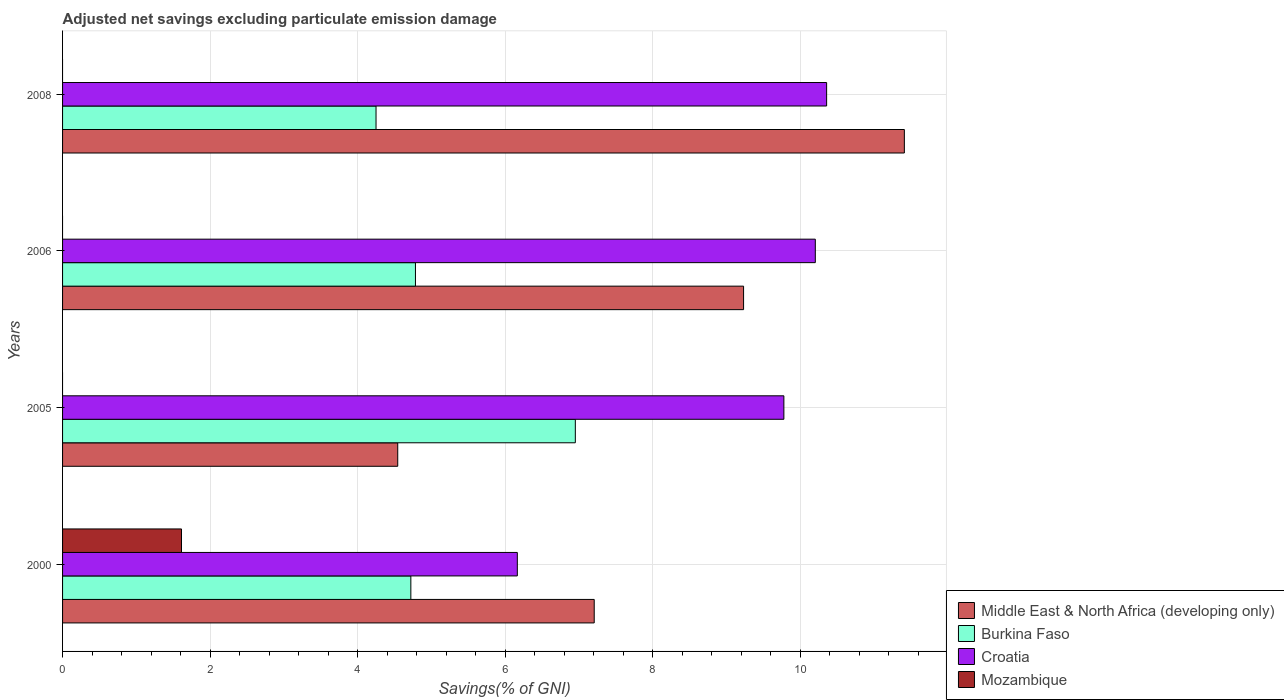How many different coloured bars are there?
Ensure brevity in your answer.  4. How many groups of bars are there?
Keep it short and to the point. 4. Are the number of bars per tick equal to the number of legend labels?
Offer a very short reply. No. How many bars are there on the 4th tick from the top?
Give a very brief answer. 4. In how many cases, is the number of bars for a given year not equal to the number of legend labels?
Offer a very short reply. 3. What is the adjusted net savings in Croatia in 2006?
Provide a short and direct response. 10.2. Across all years, what is the maximum adjusted net savings in Croatia?
Make the answer very short. 10.36. Across all years, what is the minimum adjusted net savings in Mozambique?
Offer a terse response. 0. What is the total adjusted net savings in Burkina Faso in the graph?
Provide a short and direct response. 20.71. What is the difference between the adjusted net savings in Burkina Faso in 2000 and that in 2006?
Offer a very short reply. -0.06. What is the difference between the adjusted net savings in Burkina Faso in 2006 and the adjusted net savings in Croatia in 2000?
Make the answer very short. -1.38. What is the average adjusted net savings in Burkina Faso per year?
Your answer should be compact. 5.18. In the year 2000, what is the difference between the adjusted net savings in Middle East & North Africa (developing only) and adjusted net savings in Burkina Faso?
Offer a very short reply. 2.49. What is the ratio of the adjusted net savings in Middle East & North Africa (developing only) in 2000 to that in 2006?
Offer a terse response. 0.78. Is the difference between the adjusted net savings in Middle East & North Africa (developing only) in 2000 and 2005 greater than the difference between the adjusted net savings in Burkina Faso in 2000 and 2005?
Your response must be concise. Yes. What is the difference between the highest and the second highest adjusted net savings in Middle East & North Africa (developing only)?
Provide a short and direct response. 2.18. What is the difference between the highest and the lowest adjusted net savings in Burkina Faso?
Your answer should be compact. 2.7. In how many years, is the adjusted net savings in Middle East & North Africa (developing only) greater than the average adjusted net savings in Middle East & North Africa (developing only) taken over all years?
Your answer should be compact. 2. Is the sum of the adjusted net savings in Burkina Faso in 2000 and 2006 greater than the maximum adjusted net savings in Croatia across all years?
Provide a succinct answer. No. Does the graph contain grids?
Your answer should be compact. Yes. Where does the legend appear in the graph?
Offer a very short reply. Bottom right. What is the title of the graph?
Offer a terse response. Adjusted net savings excluding particulate emission damage. What is the label or title of the X-axis?
Offer a terse response. Savings(% of GNI). What is the Savings(% of GNI) of Middle East & North Africa (developing only) in 2000?
Make the answer very short. 7.21. What is the Savings(% of GNI) of Burkina Faso in 2000?
Your answer should be compact. 4.72. What is the Savings(% of GNI) of Croatia in 2000?
Ensure brevity in your answer.  6.16. What is the Savings(% of GNI) in Mozambique in 2000?
Your response must be concise. 1.61. What is the Savings(% of GNI) of Middle East & North Africa (developing only) in 2005?
Offer a terse response. 4.54. What is the Savings(% of GNI) in Burkina Faso in 2005?
Ensure brevity in your answer.  6.95. What is the Savings(% of GNI) of Croatia in 2005?
Keep it short and to the point. 9.78. What is the Savings(% of GNI) of Middle East & North Africa (developing only) in 2006?
Provide a short and direct response. 9.23. What is the Savings(% of GNI) in Burkina Faso in 2006?
Ensure brevity in your answer.  4.78. What is the Savings(% of GNI) in Croatia in 2006?
Offer a terse response. 10.2. What is the Savings(% of GNI) in Middle East & North Africa (developing only) in 2008?
Provide a succinct answer. 11.41. What is the Savings(% of GNI) in Burkina Faso in 2008?
Your answer should be compact. 4.25. What is the Savings(% of GNI) in Croatia in 2008?
Ensure brevity in your answer.  10.36. Across all years, what is the maximum Savings(% of GNI) in Middle East & North Africa (developing only)?
Your answer should be very brief. 11.41. Across all years, what is the maximum Savings(% of GNI) in Burkina Faso?
Offer a terse response. 6.95. Across all years, what is the maximum Savings(% of GNI) of Croatia?
Make the answer very short. 10.36. Across all years, what is the maximum Savings(% of GNI) of Mozambique?
Keep it short and to the point. 1.61. Across all years, what is the minimum Savings(% of GNI) of Middle East & North Africa (developing only)?
Your answer should be compact. 4.54. Across all years, what is the minimum Savings(% of GNI) of Burkina Faso?
Keep it short and to the point. 4.25. Across all years, what is the minimum Savings(% of GNI) in Croatia?
Offer a terse response. 6.16. What is the total Savings(% of GNI) in Middle East & North Africa (developing only) in the graph?
Keep it short and to the point. 32.39. What is the total Savings(% of GNI) of Burkina Faso in the graph?
Your answer should be very brief. 20.71. What is the total Savings(% of GNI) of Croatia in the graph?
Provide a short and direct response. 36.51. What is the total Savings(% of GNI) in Mozambique in the graph?
Provide a short and direct response. 1.61. What is the difference between the Savings(% of GNI) of Middle East & North Africa (developing only) in 2000 and that in 2005?
Offer a very short reply. 2.66. What is the difference between the Savings(% of GNI) in Burkina Faso in 2000 and that in 2005?
Your answer should be compact. -2.23. What is the difference between the Savings(% of GNI) in Croatia in 2000 and that in 2005?
Ensure brevity in your answer.  -3.61. What is the difference between the Savings(% of GNI) of Middle East & North Africa (developing only) in 2000 and that in 2006?
Your response must be concise. -2.02. What is the difference between the Savings(% of GNI) of Burkina Faso in 2000 and that in 2006?
Keep it short and to the point. -0.06. What is the difference between the Savings(% of GNI) in Croatia in 2000 and that in 2006?
Give a very brief answer. -4.04. What is the difference between the Savings(% of GNI) of Middle East & North Africa (developing only) in 2000 and that in 2008?
Keep it short and to the point. -4.2. What is the difference between the Savings(% of GNI) in Burkina Faso in 2000 and that in 2008?
Ensure brevity in your answer.  0.47. What is the difference between the Savings(% of GNI) of Croatia in 2000 and that in 2008?
Offer a terse response. -4.19. What is the difference between the Savings(% of GNI) of Middle East & North Africa (developing only) in 2005 and that in 2006?
Your answer should be compact. -4.69. What is the difference between the Savings(% of GNI) of Burkina Faso in 2005 and that in 2006?
Provide a succinct answer. 2.17. What is the difference between the Savings(% of GNI) of Croatia in 2005 and that in 2006?
Your answer should be compact. -0.43. What is the difference between the Savings(% of GNI) of Middle East & North Africa (developing only) in 2005 and that in 2008?
Offer a terse response. -6.87. What is the difference between the Savings(% of GNI) in Burkina Faso in 2005 and that in 2008?
Provide a short and direct response. 2.7. What is the difference between the Savings(% of GNI) in Croatia in 2005 and that in 2008?
Give a very brief answer. -0.58. What is the difference between the Savings(% of GNI) in Middle East & North Africa (developing only) in 2006 and that in 2008?
Ensure brevity in your answer.  -2.18. What is the difference between the Savings(% of GNI) in Burkina Faso in 2006 and that in 2008?
Your answer should be very brief. 0.53. What is the difference between the Savings(% of GNI) of Croatia in 2006 and that in 2008?
Give a very brief answer. -0.15. What is the difference between the Savings(% of GNI) of Middle East & North Africa (developing only) in 2000 and the Savings(% of GNI) of Burkina Faso in 2005?
Provide a succinct answer. 0.26. What is the difference between the Savings(% of GNI) of Middle East & North Africa (developing only) in 2000 and the Savings(% of GNI) of Croatia in 2005?
Give a very brief answer. -2.57. What is the difference between the Savings(% of GNI) in Burkina Faso in 2000 and the Savings(% of GNI) in Croatia in 2005?
Make the answer very short. -5.06. What is the difference between the Savings(% of GNI) of Middle East & North Africa (developing only) in 2000 and the Savings(% of GNI) of Burkina Faso in 2006?
Provide a succinct answer. 2.42. What is the difference between the Savings(% of GNI) of Middle East & North Africa (developing only) in 2000 and the Savings(% of GNI) of Croatia in 2006?
Offer a terse response. -3. What is the difference between the Savings(% of GNI) of Burkina Faso in 2000 and the Savings(% of GNI) of Croatia in 2006?
Give a very brief answer. -5.48. What is the difference between the Savings(% of GNI) of Middle East & North Africa (developing only) in 2000 and the Savings(% of GNI) of Burkina Faso in 2008?
Provide a succinct answer. 2.96. What is the difference between the Savings(% of GNI) of Middle East & North Africa (developing only) in 2000 and the Savings(% of GNI) of Croatia in 2008?
Your answer should be very brief. -3.15. What is the difference between the Savings(% of GNI) of Burkina Faso in 2000 and the Savings(% of GNI) of Croatia in 2008?
Offer a very short reply. -5.64. What is the difference between the Savings(% of GNI) of Middle East & North Africa (developing only) in 2005 and the Savings(% of GNI) of Burkina Faso in 2006?
Give a very brief answer. -0.24. What is the difference between the Savings(% of GNI) in Middle East & North Africa (developing only) in 2005 and the Savings(% of GNI) in Croatia in 2006?
Keep it short and to the point. -5.66. What is the difference between the Savings(% of GNI) in Burkina Faso in 2005 and the Savings(% of GNI) in Croatia in 2006?
Keep it short and to the point. -3.25. What is the difference between the Savings(% of GNI) of Middle East & North Africa (developing only) in 2005 and the Savings(% of GNI) of Burkina Faso in 2008?
Your response must be concise. 0.29. What is the difference between the Savings(% of GNI) of Middle East & North Africa (developing only) in 2005 and the Savings(% of GNI) of Croatia in 2008?
Give a very brief answer. -5.81. What is the difference between the Savings(% of GNI) of Burkina Faso in 2005 and the Savings(% of GNI) of Croatia in 2008?
Provide a succinct answer. -3.41. What is the difference between the Savings(% of GNI) in Middle East & North Africa (developing only) in 2006 and the Savings(% of GNI) in Burkina Faso in 2008?
Your answer should be compact. 4.98. What is the difference between the Savings(% of GNI) of Middle East & North Africa (developing only) in 2006 and the Savings(% of GNI) of Croatia in 2008?
Provide a succinct answer. -1.13. What is the difference between the Savings(% of GNI) in Burkina Faso in 2006 and the Savings(% of GNI) in Croatia in 2008?
Make the answer very short. -5.57. What is the average Savings(% of GNI) in Middle East & North Africa (developing only) per year?
Offer a very short reply. 8.1. What is the average Savings(% of GNI) of Burkina Faso per year?
Give a very brief answer. 5.18. What is the average Savings(% of GNI) in Croatia per year?
Provide a succinct answer. 9.13. What is the average Savings(% of GNI) in Mozambique per year?
Your answer should be very brief. 0.4. In the year 2000, what is the difference between the Savings(% of GNI) of Middle East & North Africa (developing only) and Savings(% of GNI) of Burkina Faso?
Offer a terse response. 2.49. In the year 2000, what is the difference between the Savings(% of GNI) of Middle East & North Africa (developing only) and Savings(% of GNI) of Croatia?
Give a very brief answer. 1.04. In the year 2000, what is the difference between the Savings(% of GNI) in Middle East & North Africa (developing only) and Savings(% of GNI) in Mozambique?
Your answer should be compact. 5.59. In the year 2000, what is the difference between the Savings(% of GNI) of Burkina Faso and Savings(% of GNI) of Croatia?
Provide a short and direct response. -1.44. In the year 2000, what is the difference between the Savings(% of GNI) in Burkina Faso and Savings(% of GNI) in Mozambique?
Provide a short and direct response. 3.11. In the year 2000, what is the difference between the Savings(% of GNI) in Croatia and Savings(% of GNI) in Mozambique?
Your answer should be very brief. 4.55. In the year 2005, what is the difference between the Savings(% of GNI) in Middle East & North Africa (developing only) and Savings(% of GNI) in Burkina Faso?
Provide a succinct answer. -2.41. In the year 2005, what is the difference between the Savings(% of GNI) of Middle East & North Africa (developing only) and Savings(% of GNI) of Croatia?
Provide a succinct answer. -5.23. In the year 2005, what is the difference between the Savings(% of GNI) of Burkina Faso and Savings(% of GNI) of Croatia?
Give a very brief answer. -2.83. In the year 2006, what is the difference between the Savings(% of GNI) of Middle East & North Africa (developing only) and Savings(% of GNI) of Burkina Faso?
Keep it short and to the point. 4.45. In the year 2006, what is the difference between the Savings(% of GNI) in Middle East & North Africa (developing only) and Savings(% of GNI) in Croatia?
Ensure brevity in your answer.  -0.97. In the year 2006, what is the difference between the Savings(% of GNI) in Burkina Faso and Savings(% of GNI) in Croatia?
Provide a succinct answer. -5.42. In the year 2008, what is the difference between the Savings(% of GNI) of Middle East & North Africa (developing only) and Savings(% of GNI) of Burkina Faso?
Give a very brief answer. 7.16. In the year 2008, what is the difference between the Savings(% of GNI) of Middle East & North Africa (developing only) and Savings(% of GNI) of Croatia?
Make the answer very short. 1.05. In the year 2008, what is the difference between the Savings(% of GNI) of Burkina Faso and Savings(% of GNI) of Croatia?
Provide a succinct answer. -6.11. What is the ratio of the Savings(% of GNI) in Middle East & North Africa (developing only) in 2000 to that in 2005?
Provide a short and direct response. 1.59. What is the ratio of the Savings(% of GNI) in Burkina Faso in 2000 to that in 2005?
Provide a succinct answer. 0.68. What is the ratio of the Savings(% of GNI) of Croatia in 2000 to that in 2005?
Provide a succinct answer. 0.63. What is the ratio of the Savings(% of GNI) of Middle East & North Africa (developing only) in 2000 to that in 2006?
Keep it short and to the point. 0.78. What is the ratio of the Savings(% of GNI) in Burkina Faso in 2000 to that in 2006?
Provide a succinct answer. 0.99. What is the ratio of the Savings(% of GNI) of Croatia in 2000 to that in 2006?
Provide a succinct answer. 0.6. What is the ratio of the Savings(% of GNI) in Middle East & North Africa (developing only) in 2000 to that in 2008?
Make the answer very short. 0.63. What is the ratio of the Savings(% of GNI) in Burkina Faso in 2000 to that in 2008?
Offer a terse response. 1.11. What is the ratio of the Savings(% of GNI) in Croatia in 2000 to that in 2008?
Your answer should be compact. 0.6. What is the ratio of the Savings(% of GNI) in Middle East & North Africa (developing only) in 2005 to that in 2006?
Give a very brief answer. 0.49. What is the ratio of the Savings(% of GNI) in Burkina Faso in 2005 to that in 2006?
Your answer should be compact. 1.45. What is the ratio of the Savings(% of GNI) of Croatia in 2005 to that in 2006?
Ensure brevity in your answer.  0.96. What is the ratio of the Savings(% of GNI) in Middle East & North Africa (developing only) in 2005 to that in 2008?
Give a very brief answer. 0.4. What is the ratio of the Savings(% of GNI) of Burkina Faso in 2005 to that in 2008?
Keep it short and to the point. 1.64. What is the ratio of the Savings(% of GNI) of Croatia in 2005 to that in 2008?
Make the answer very short. 0.94. What is the ratio of the Savings(% of GNI) of Middle East & North Africa (developing only) in 2006 to that in 2008?
Provide a short and direct response. 0.81. What is the ratio of the Savings(% of GNI) in Burkina Faso in 2006 to that in 2008?
Give a very brief answer. 1.13. What is the ratio of the Savings(% of GNI) of Croatia in 2006 to that in 2008?
Ensure brevity in your answer.  0.99. What is the difference between the highest and the second highest Savings(% of GNI) of Middle East & North Africa (developing only)?
Offer a very short reply. 2.18. What is the difference between the highest and the second highest Savings(% of GNI) in Burkina Faso?
Give a very brief answer. 2.17. What is the difference between the highest and the second highest Savings(% of GNI) of Croatia?
Offer a very short reply. 0.15. What is the difference between the highest and the lowest Savings(% of GNI) in Middle East & North Africa (developing only)?
Give a very brief answer. 6.87. What is the difference between the highest and the lowest Savings(% of GNI) in Burkina Faso?
Make the answer very short. 2.7. What is the difference between the highest and the lowest Savings(% of GNI) of Croatia?
Make the answer very short. 4.19. What is the difference between the highest and the lowest Savings(% of GNI) of Mozambique?
Ensure brevity in your answer.  1.61. 